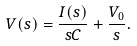Convert formula to latex. <formula><loc_0><loc_0><loc_500><loc_500>V ( s ) = { \frac { I ( s ) } { s C } } + { \frac { V _ { 0 } } { s } } .</formula> 